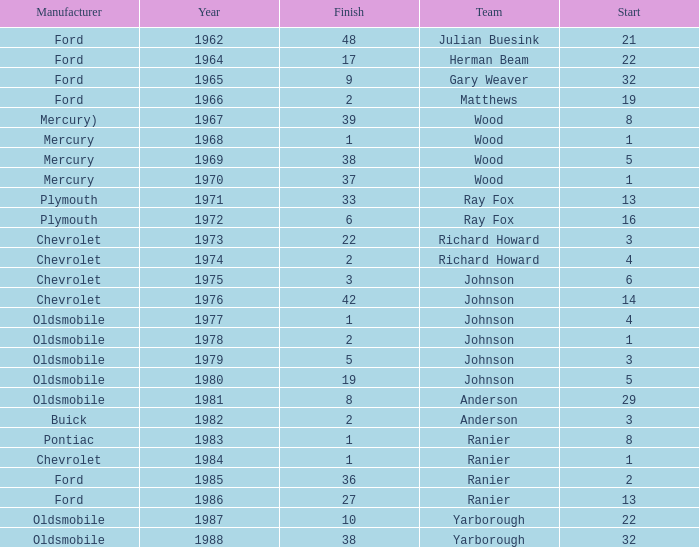Who was the maufacturer of the vehicle during the race where Cale Yarborough started at 19 and finished earlier than 42? Ford. 